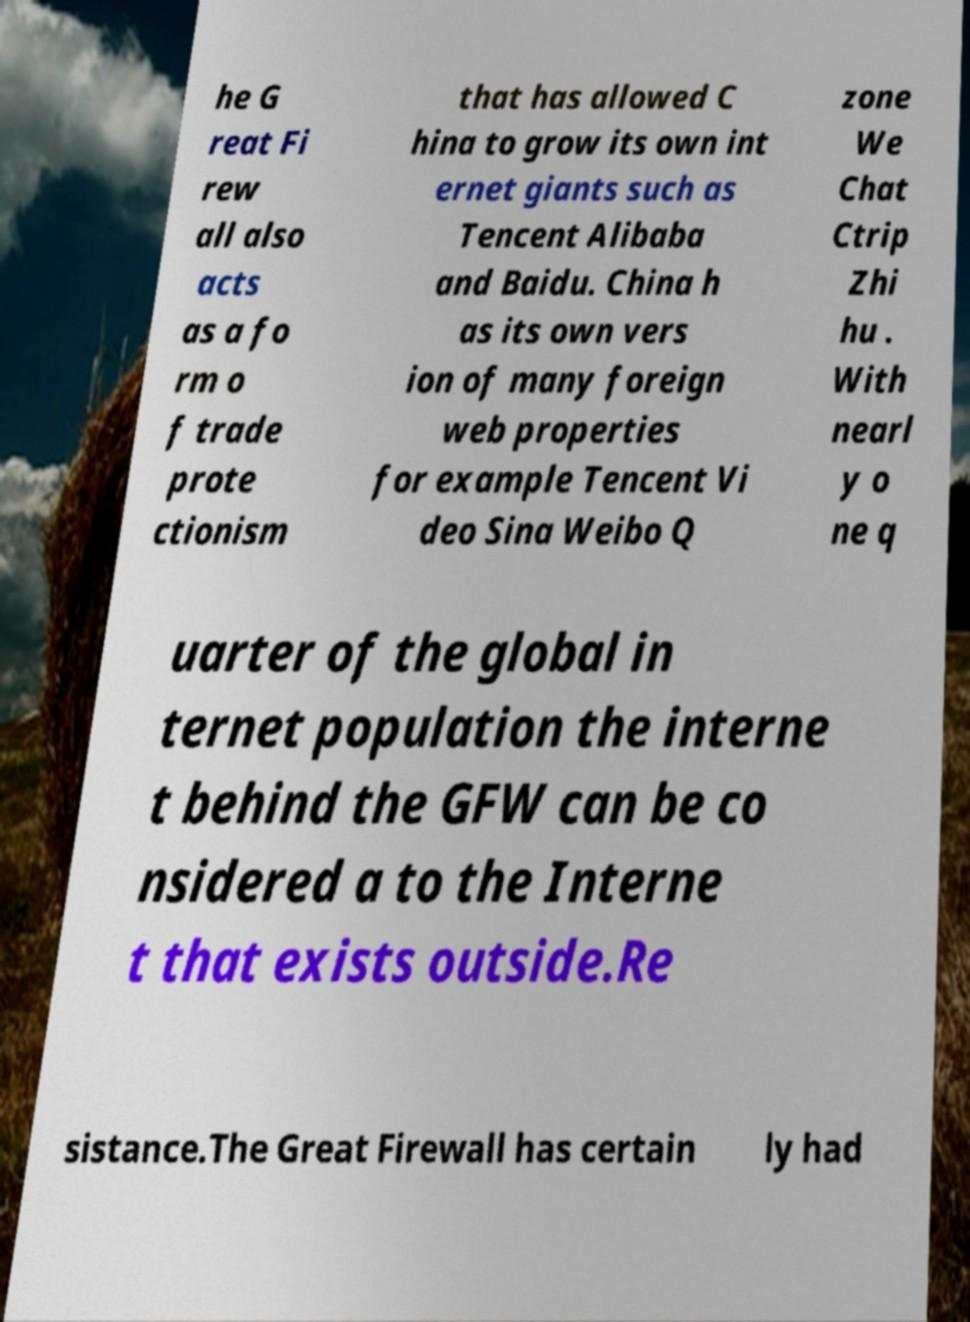For documentation purposes, I need the text within this image transcribed. Could you provide that? he G reat Fi rew all also acts as a fo rm o f trade prote ctionism that has allowed C hina to grow its own int ernet giants such as Tencent Alibaba and Baidu. China h as its own vers ion of many foreign web properties for example Tencent Vi deo Sina Weibo Q zone We Chat Ctrip Zhi hu . With nearl y o ne q uarter of the global in ternet population the interne t behind the GFW can be co nsidered a to the Interne t that exists outside.Re sistance.The Great Firewall has certain ly had 